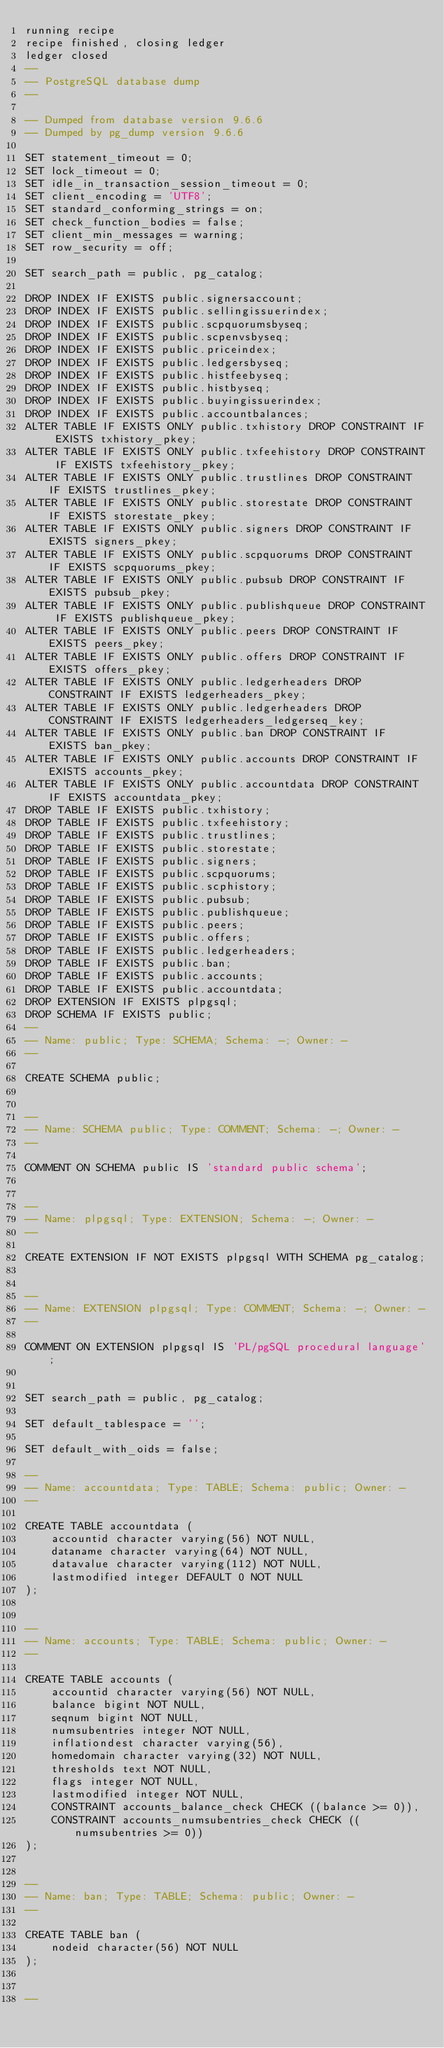Convert code to text. <code><loc_0><loc_0><loc_500><loc_500><_SQL_>running recipe
recipe finished, closing ledger
ledger closed
--
-- PostgreSQL database dump
--

-- Dumped from database version 9.6.6
-- Dumped by pg_dump version 9.6.6

SET statement_timeout = 0;
SET lock_timeout = 0;
SET idle_in_transaction_session_timeout = 0;
SET client_encoding = 'UTF8';
SET standard_conforming_strings = on;
SET check_function_bodies = false;
SET client_min_messages = warning;
SET row_security = off;

SET search_path = public, pg_catalog;

DROP INDEX IF EXISTS public.signersaccount;
DROP INDEX IF EXISTS public.sellingissuerindex;
DROP INDEX IF EXISTS public.scpquorumsbyseq;
DROP INDEX IF EXISTS public.scpenvsbyseq;
DROP INDEX IF EXISTS public.priceindex;
DROP INDEX IF EXISTS public.ledgersbyseq;
DROP INDEX IF EXISTS public.histfeebyseq;
DROP INDEX IF EXISTS public.histbyseq;
DROP INDEX IF EXISTS public.buyingissuerindex;
DROP INDEX IF EXISTS public.accountbalances;
ALTER TABLE IF EXISTS ONLY public.txhistory DROP CONSTRAINT IF EXISTS txhistory_pkey;
ALTER TABLE IF EXISTS ONLY public.txfeehistory DROP CONSTRAINT IF EXISTS txfeehistory_pkey;
ALTER TABLE IF EXISTS ONLY public.trustlines DROP CONSTRAINT IF EXISTS trustlines_pkey;
ALTER TABLE IF EXISTS ONLY public.storestate DROP CONSTRAINT IF EXISTS storestate_pkey;
ALTER TABLE IF EXISTS ONLY public.signers DROP CONSTRAINT IF EXISTS signers_pkey;
ALTER TABLE IF EXISTS ONLY public.scpquorums DROP CONSTRAINT IF EXISTS scpquorums_pkey;
ALTER TABLE IF EXISTS ONLY public.pubsub DROP CONSTRAINT IF EXISTS pubsub_pkey;
ALTER TABLE IF EXISTS ONLY public.publishqueue DROP CONSTRAINT IF EXISTS publishqueue_pkey;
ALTER TABLE IF EXISTS ONLY public.peers DROP CONSTRAINT IF EXISTS peers_pkey;
ALTER TABLE IF EXISTS ONLY public.offers DROP CONSTRAINT IF EXISTS offers_pkey;
ALTER TABLE IF EXISTS ONLY public.ledgerheaders DROP CONSTRAINT IF EXISTS ledgerheaders_pkey;
ALTER TABLE IF EXISTS ONLY public.ledgerheaders DROP CONSTRAINT IF EXISTS ledgerheaders_ledgerseq_key;
ALTER TABLE IF EXISTS ONLY public.ban DROP CONSTRAINT IF EXISTS ban_pkey;
ALTER TABLE IF EXISTS ONLY public.accounts DROP CONSTRAINT IF EXISTS accounts_pkey;
ALTER TABLE IF EXISTS ONLY public.accountdata DROP CONSTRAINT IF EXISTS accountdata_pkey;
DROP TABLE IF EXISTS public.txhistory;
DROP TABLE IF EXISTS public.txfeehistory;
DROP TABLE IF EXISTS public.trustlines;
DROP TABLE IF EXISTS public.storestate;
DROP TABLE IF EXISTS public.signers;
DROP TABLE IF EXISTS public.scpquorums;
DROP TABLE IF EXISTS public.scphistory;
DROP TABLE IF EXISTS public.pubsub;
DROP TABLE IF EXISTS public.publishqueue;
DROP TABLE IF EXISTS public.peers;
DROP TABLE IF EXISTS public.offers;
DROP TABLE IF EXISTS public.ledgerheaders;
DROP TABLE IF EXISTS public.ban;
DROP TABLE IF EXISTS public.accounts;
DROP TABLE IF EXISTS public.accountdata;
DROP EXTENSION IF EXISTS plpgsql;
DROP SCHEMA IF EXISTS public;
--
-- Name: public; Type: SCHEMA; Schema: -; Owner: -
--

CREATE SCHEMA public;


--
-- Name: SCHEMA public; Type: COMMENT; Schema: -; Owner: -
--

COMMENT ON SCHEMA public IS 'standard public schema';


--
-- Name: plpgsql; Type: EXTENSION; Schema: -; Owner: -
--

CREATE EXTENSION IF NOT EXISTS plpgsql WITH SCHEMA pg_catalog;


--
-- Name: EXTENSION plpgsql; Type: COMMENT; Schema: -; Owner: -
--

COMMENT ON EXTENSION plpgsql IS 'PL/pgSQL procedural language';


SET search_path = public, pg_catalog;

SET default_tablespace = '';

SET default_with_oids = false;

--
-- Name: accountdata; Type: TABLE; Schema: public; Owner: -
--

CREATE TABLE accountdata (
    accountid character varying(56) NOT NULL,
    dataname character varying(64) NOT NULL,
    datavalue character varying(112) NOT NULL,
    lastmodified integer DEFAULT 0 NOT NULL
);


--
-- Name: accounts; Type: TABLE; Schema: public; Owner: -
--

CREATE TABLE accounts (
    accountid character varying(56) NOT NULL,
    balance bigint NOT NULL,
    seqnum bigint NOT NULL,
    numsubentries integer NOT NULL,
    inflationdest character varying(56),
    homedomain character varying(32) NOT NULL,
    thresholds text NOT NULL,
    flags integer NOT NULL,
    lastmodified integer NOT NULL,
    CONSTRAINT accounts_balance_check CHECK ((balance >= 0)),
    CONSTRAINT accounts_numsubentries_check CHECK ((numsubentries >= 0))
);


--
-- Name: ban; Type: TABLE; Schema: public; Owner: -
--

CREATE TABLE ban (
    nodeid character(56) NOT NULL
);


--</code> 